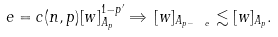<formula> <loc_0><loc_0><loc_500><loc_500>\ e = c ( n , p ) [ w ] _ { A _ { p } } ^ { 1 - p ^ { \prime } } \Rightarrow \, [ w ] _ { A _ { p - \ e } } \lesssim [ w ] _ { A _ { p } } .</formula> 